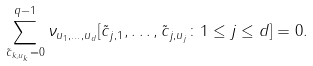Convert formula to latex. <formula><loc_0><loc_0><loc_500><loc_500>\sum _ { \tilde { c } _ { k , u _ { k } } = 0 } ^ { q - 1 } \nu _ { u _ { 1 } , \dots , u _ { d } } [ \tilde { c } _ { j , 1 } , \dots , \tilde { c } _ { j , u _ { j } } \colon 1 \leq j \leq d ] = 0 .</formula> 